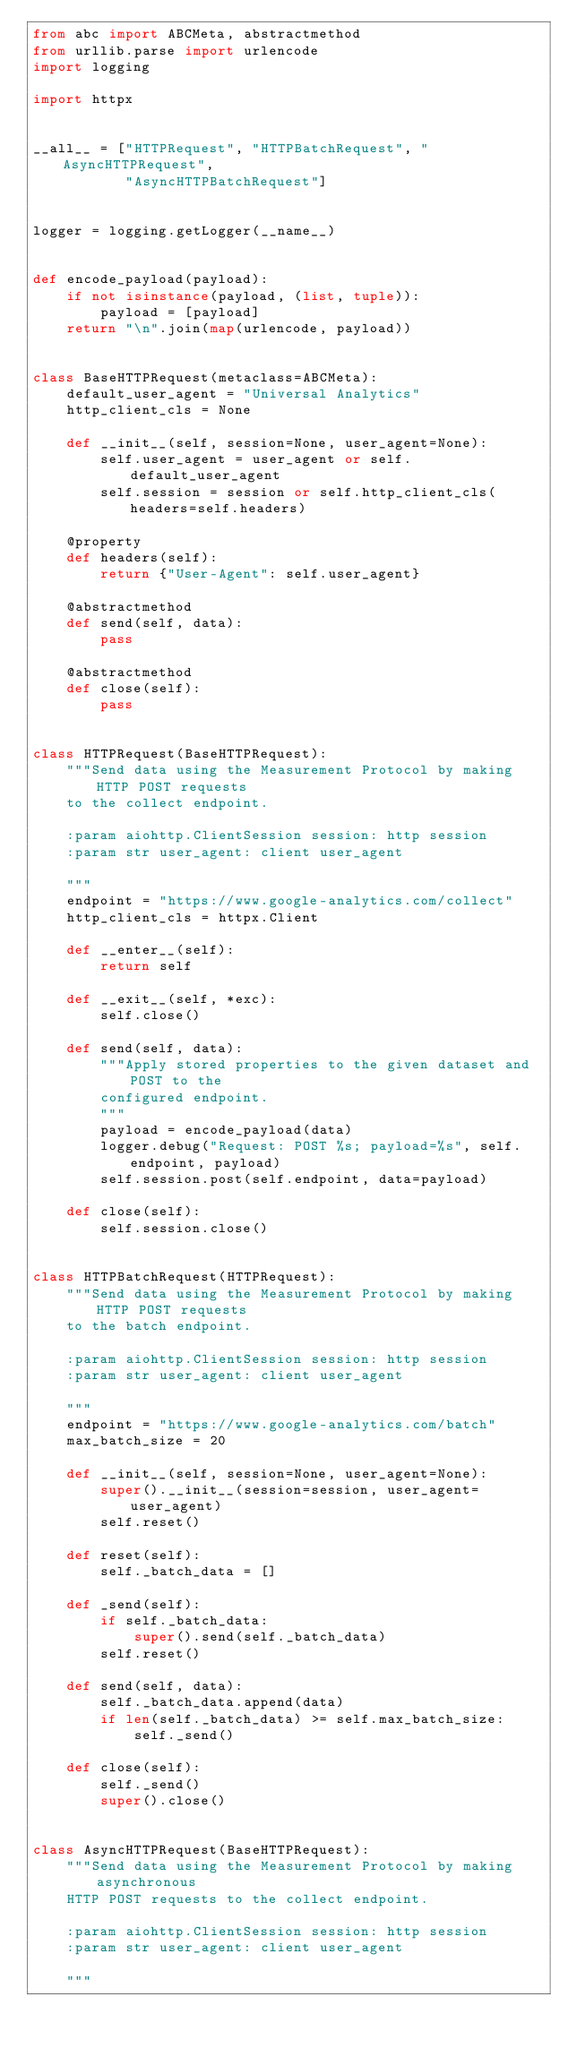<code> <loc_0><loc_0><loc_500><loc_500><_Python_>from abc import ABCMeta, abstractmethod
from urllib.parse import urlencode
import logging

import httpx


__all__ = ["HTTPRequest", "HTTPBatchRequest", "AsyncHTTPRequest",
           "AsyncHTTPBatchRequest"]


logger = logging.getLogger(__name__)


def encode_payload(payload):
    if not isinstance(payload, (list, tuple)):
        payload = [payload]
    return "\n".join(map(urlencode, payload))


class BaseHTTPRequest(metaclass=ABCMeta):
    default_user_agent = "Universal Analytics"
    http_client_cls = None

    def __init__(self, session=None, user_agent=None):
        self.user_agent = user_agent or self.default_user_agent
        self.session = session or self.http_client_cls(headers=self.headers)

    @property
    def headers(self):
        return {"User-Agent": self.user_agent}

    @abstractmethod
    def send(self, data):
        pass

    @abstractmethod
    def close(self):
        pass


class HTTPRequest(BaseHTTPRequest):
    """Send data using the Measurement Protocol by making HTTP POST requests
    to the collect endpoint.

    :param aiohttp.ClientSession session: http session
    :param str user_agent: client user_agent

    """
    endpoint = "https://www.google-analytics.com/collect"
    http_client_cls = httpx.Client

    def __enter__(self):
        return self

    def __exit__(self, *exc):
        self.close()

    def send(self, data):
        """Apply stored properties to the given dataset and POST to the
        configured endpoint.
        """
        payload = encode_payload(data)
        logger.debug("Request: POST %s; payload=%s", self.endpoint, payload)
        self.session.post(self.endpoint, data=payload)

    def close(self):
        self.session.close()


class HTTPBatchRequest(HTTPRequest):
    """Send data using the Measurement Protocol by making HTTP POST requests
    to the batch endpoint.

    :param aiohttp.ClientSession session: http session
    :param str user_agent: client user_agent

    """
    endpoint = "https://www.google-analytics.com/batch"
    max_batch_size = 20

    def __init__(self, session=None, user_agent=None):
        super().__init__(session=session, user_agent=user_agent)
        self.reset()

    def reset(self):
        self._batch_data = []

    def _send(self):
        if self._batch_data:
            super().send(self._batch_data)
        self.reset()

    def send(self, data):
        self._batch_data.append(data)
        if len(self._batch_data) >= self.max_batch_size:
            self._send()

    def close(self):
        self._send()
        super().close()


class AsyncHTTPRequest(BaseHTTPRequest):
    """Send data using the Measurement Protocol by making asynchronous
    HTTP POST requests to the collect endpoint.

    :param aiohttp.ClientSession session: http session
    :param str user_agent: client user_agent

    """</code> 